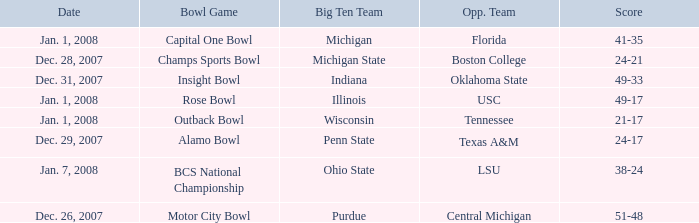What was the score of the BCS National Championship game? 38-24. 